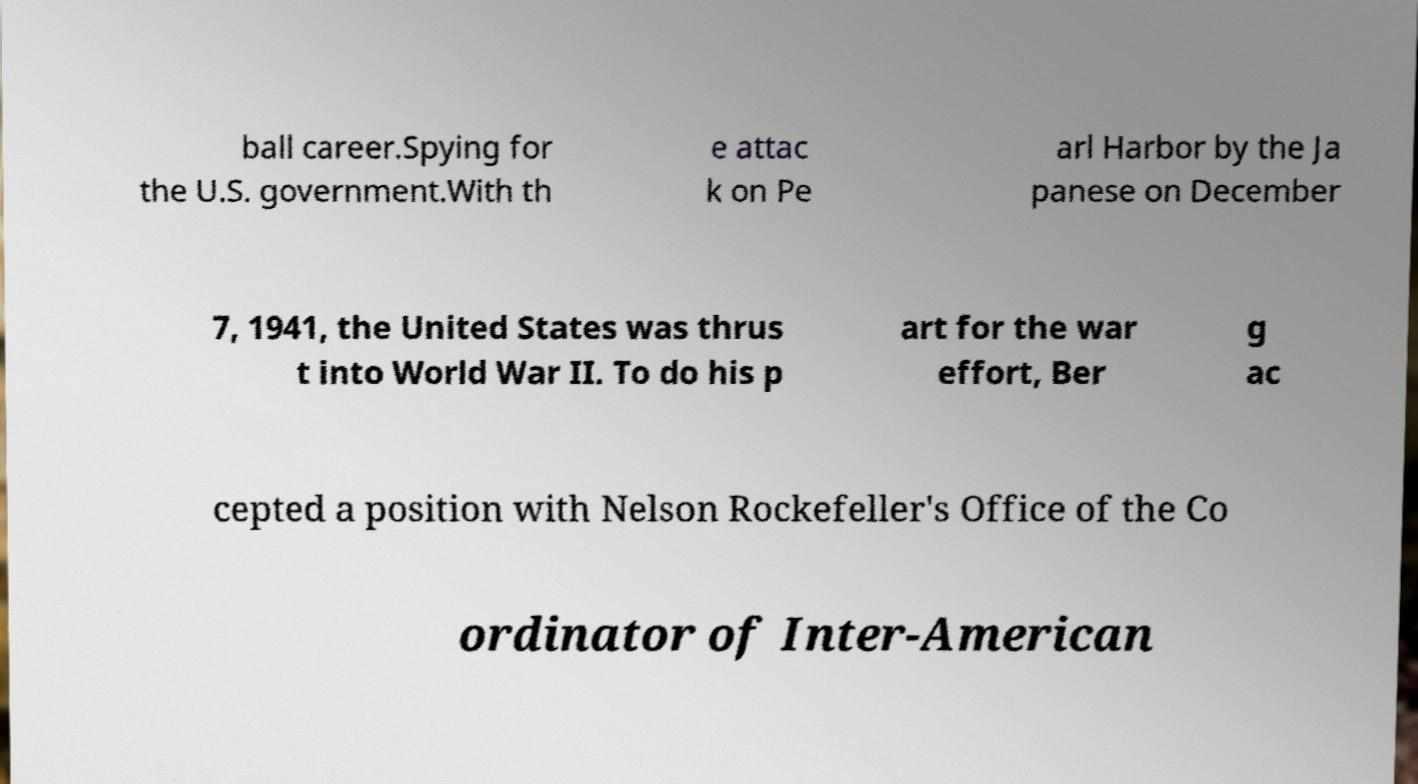Please read and relay the text visible in this image. What does it say? ball career.Spying for the U.S. government.With th e attac k on Pe arl Harbor by the Ja panese on December 7, 1941, the United States was thrus t into World War II. To do his p art for the war effort, Ber g ac cepted a position with Nelson Rockefeller's Office of the Co ordinator of Inter-American 